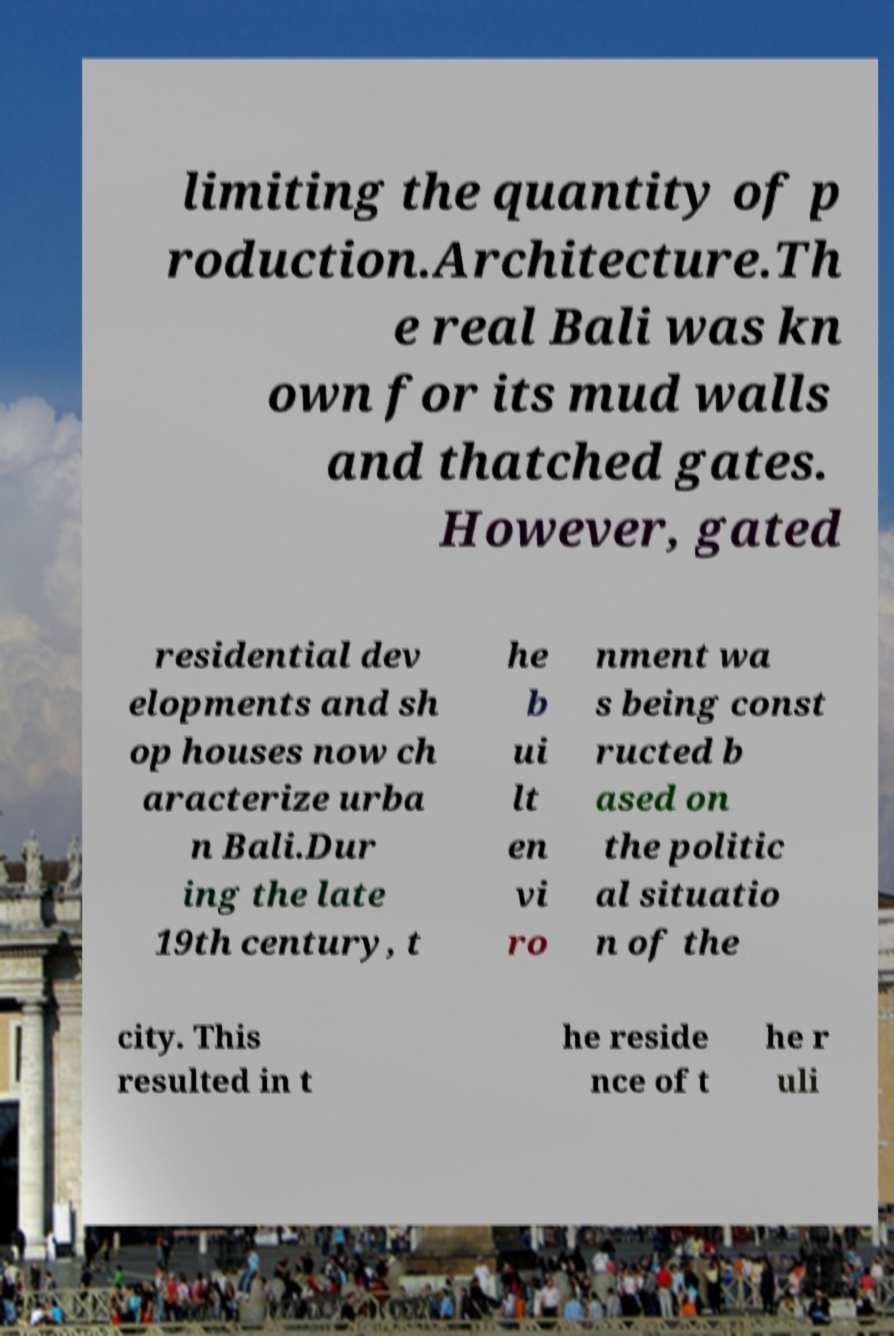Please read and relay the text visible in this image. What does it say? limiting the quantity of p roduction.Architecture.Th e real Bali was kn own for its mud walls and thatched gates. However, gated residential dev elopments and sh op houses now ch aracterize urba n Bali.Dur ing the late 19th century, t he b ui lt en vi ro nment wa s being const ructed b ased on the politic al situatio n of the city. This resulted in t he reside nce of t he r uli 